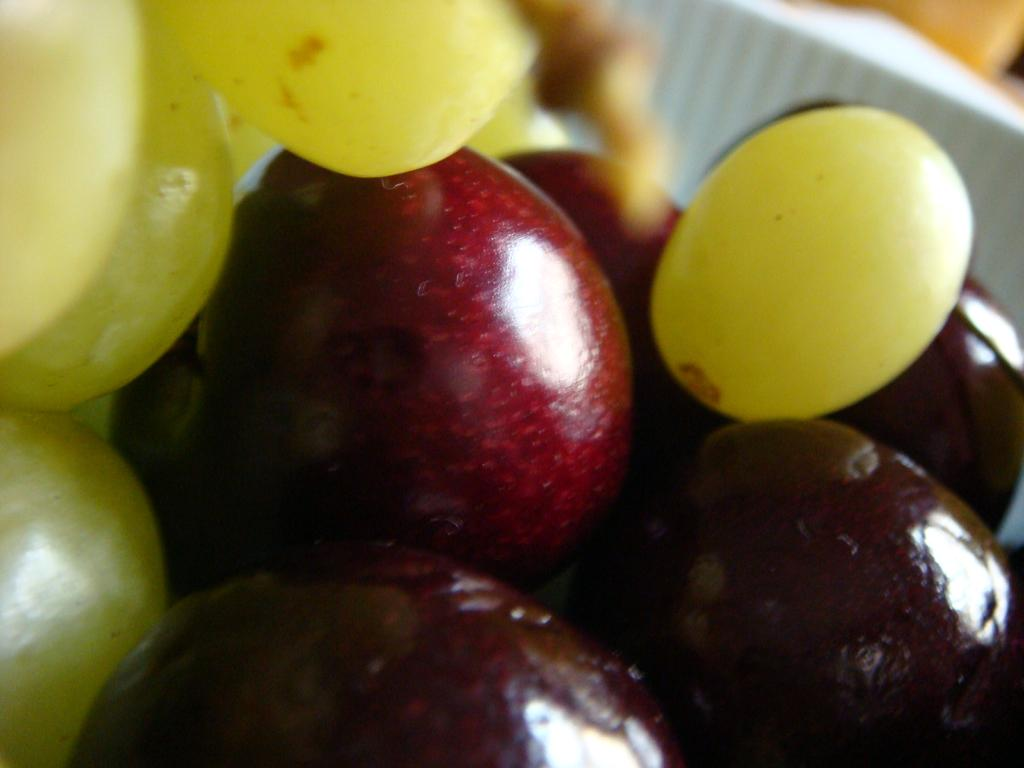What type of fruit can be seen in the foreground of the image? There are grapes and cherries in the foreground of the image. Can you describe the white object at the top of the image? Unfortunately, the facts provided do not give any information about the white object at the top of the image. What type of fiction is being read by the owl in the image? There is no owl present in the image, so it is not possible to answer that question. 